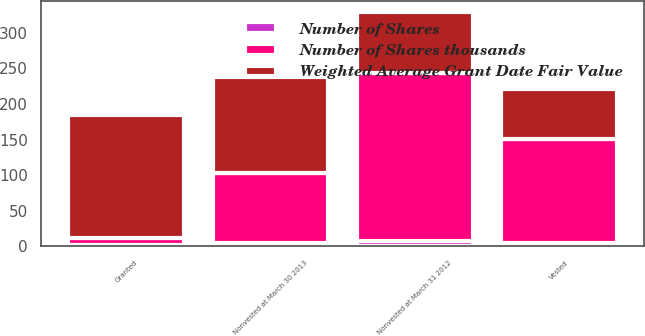<chart> <loc_0><loc_0><loc_500><loc_500><stacked_bar_chart><ecel><fcel>Nonvested at March 31 2012<fcel>Granted<fcel>Vested<fcel>Nonvested at March 30 2013<nl><fcel>Number of Shares<fcel>8<fcel>2<fcel>5<fcel>5<nl><fcel>Weighted Average Grant Date Fair Value<fcel>85.87<fcel>173.33<fcel>70.58<fcel>134.28<nl><fcel>Number of Shares thousands<fcel>235<fcel>9<fcel>146<fcel>98<nl></chart> 